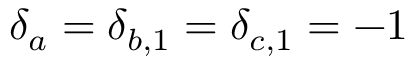<formula> <loc_0><loc_0><loc_500><loc_500>\delta _ { a } = \delta _ { b , 1 } = \delta _ { c , 1 } = - 1</formula> 